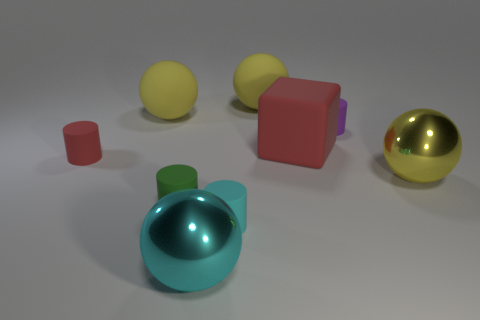How many yellow balls must be subtracted to get 1 yellow balls? 2 Add 1 big matte blocks. How many objects exist? 10 Subtract all gray cylinders. How many yellow spheres are left? 3 Subtract all purple cylinders. How many cylinders are left? 3 Subtract all cyan spheres. How many spheres are left? 3 Subtract 2 spheres. How many spheres are left? 2 Subtract all blue cylinders. Subtract all brown blocks. How many cylinders are left? 4 Subtract all cubes. How many objects are left? 8 Add 1 yellow rubber balls. How many yellow rubber balls are left? 3 Add 6 small objects. How many small objects exist? 10 